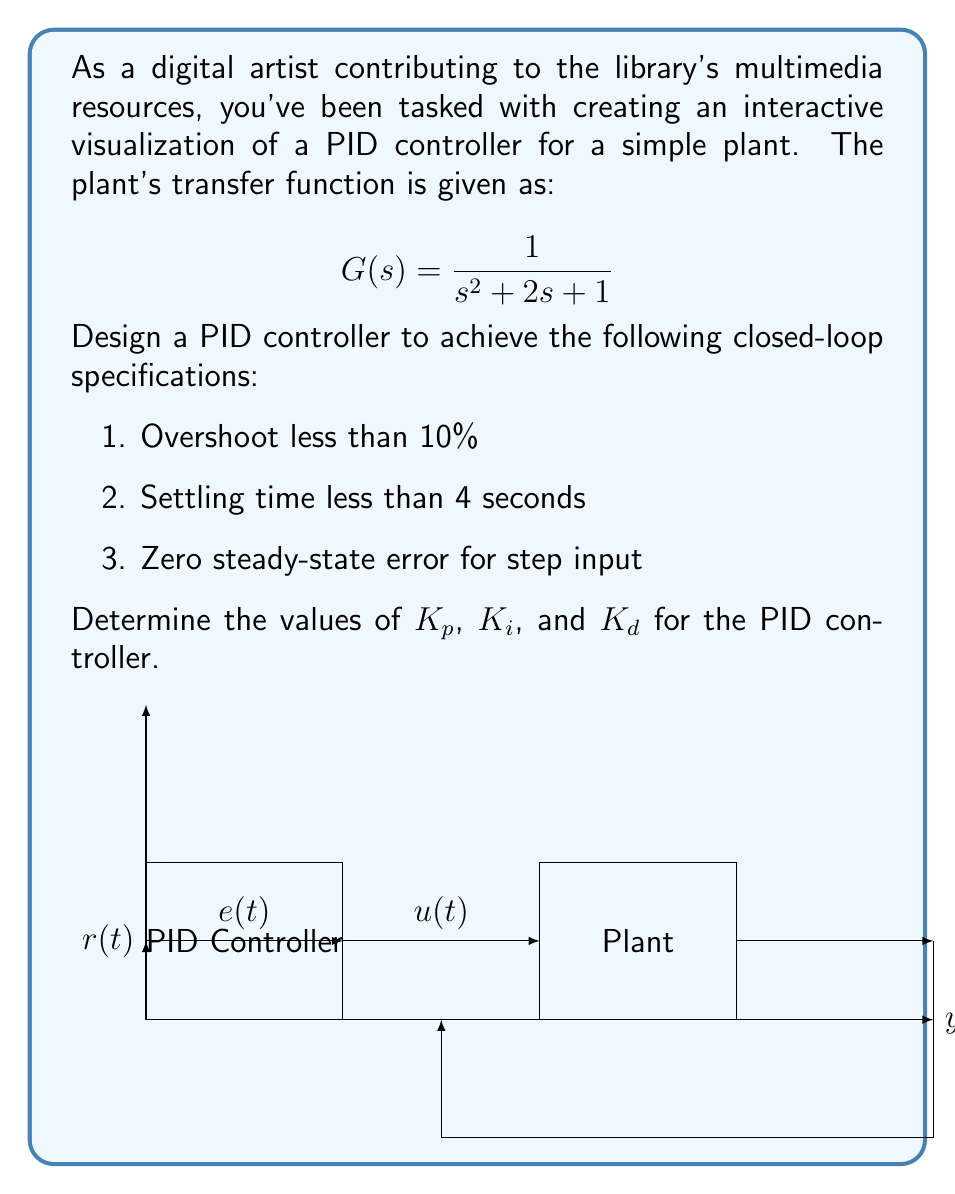Give your solution to this math problem. To design a PID controller for the given plant, we'll follow these steps:

1) The PID controller transfer function is:
   $$C(s) = K_p + \frac{K_i}{s} + K_d s$$

2) The closed-loop transfer function is:
   $$T(s) = \frac{C(s)G(s)}{1 + C(s)G(s)}$$

3) Substituting the given plant transfer function:
   $$T(s) = \frac{K_p s + K_i + K_d s^2}{s^3 + (2+K_d)s^2 + (1+K_p)s + K_i}$$

4) For a second-order approximation, we can equate this to the standard form:
   $$T(s) \approx \frac{\omega_n^2}{s^2 + 2\zeta\omega_n s + \omega_n^2}$$

5) From the overshoot specification (OS < 10%), we can determine $\zeta$:
   $$\zeta = \sqrt{\frac{\ln^2(OS/100)}{\pi^2 + \ln^2(OS/100)}} \approx 0.591$$

6) From the settling time specification ($T_s < 4s$), we can find $\omega_n$:
   $$\omega_n = \frac{4}{\zeta T_s} \approx 1.69 \text{ rad/s}$$

7) Now we can equate coefficients:
   $$2\zeta\omega_n = 2 + K_d$$
   $$\omega_n^2 = 1 + K_p$$
   $$K_i = \omega_n^2$$

8) Solving these equations:
   $$K_d = 2\zeta\omega_n - 2 \approx 0.00$$
   $$K_p = \omega_n^2 - 1 \approx 1.86$$
   $$K_i = \omega_n^2 \approx 2.86$$

These values should provide a good starting point for fine-tuning the PID controller to meet the specifications.
Answer: $K_p \approx 1.86$, $K_i \approx 2.86$, $K_d \approx 0.00$ 